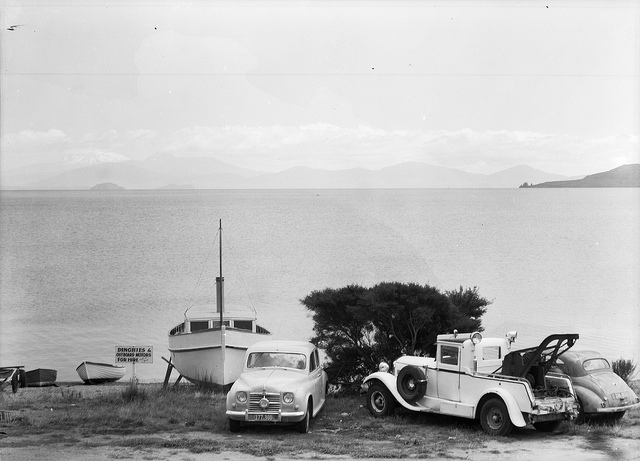<image>What color is the four door car? It is not clear what color is the four-door car. It can be seen as white or black and white. What color is the four door car? I am not sure what color is the four door car. However, it can be seen white or black and white. 